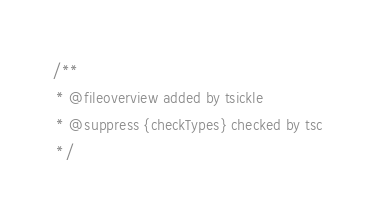<code> <loc_0><loc_0><loc_500><loc_500><_JavaScript_>/**
 * @fileoverview added by tsickle
 * @suppress {checkTypes} checked by tsc
 */</code> 